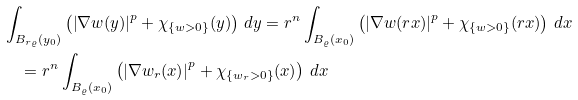<formula> <loc_0><loc_0><loc_500><loc_500>& \int _ { B _ { r \varrho } ( y _ { 0 } ) } \left ( \left | \nabla w ( y ) \right | ^ { p } + \chi _ { \left \{ w > 0 \right \} } ( y ) \right ) \, d y = { r ^ { n } } \int _ { B _ { \varrho } ( x _ { 0 } ) } \left ( \left | \nabla w ( r x ) \right | ^ { p } + \chi _ { \left \{ w > 0 \right \} } ( r x ) \right ) \, d x \\ & \quad = r ^ { n } \int _ { B _ { \varrho } ( x _ { 0 } ) } \left ( \left | \nabla w _ { r } ( x ) \right | ^ { p } + \chi _ { \left \{ w _ { r } > 0 \right \} } ( x ) \right ) \, d x</formula> 